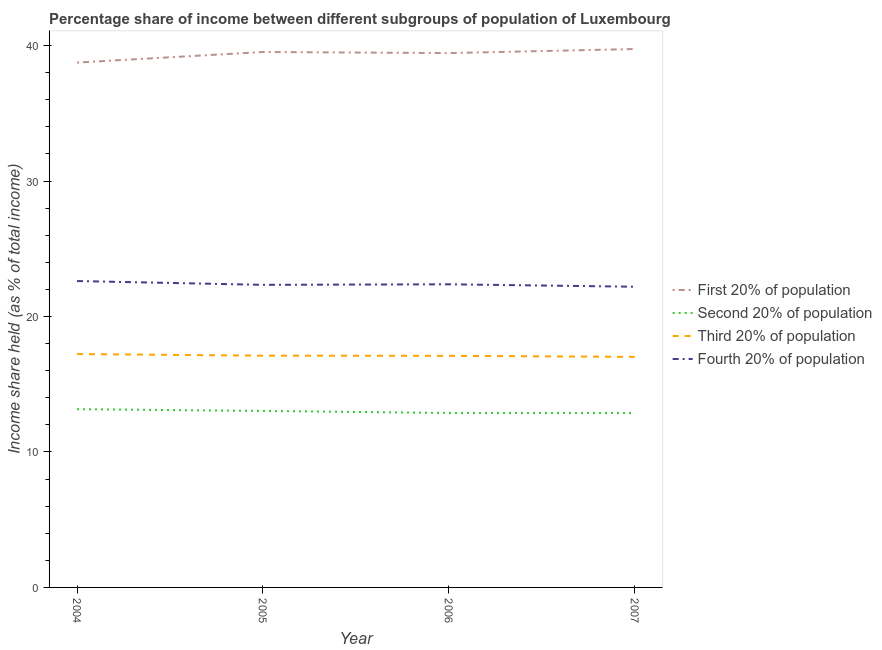How many different coloured lines are there?
Your answer should be compact. 4. Does the line corresponding to share of the income held by fourth 20% of the population intersect with the line corresponding to share of the income held by second 20% of the population?
Offer a terse response. No. What is the share of the income held by second 20% of the population in 2004?
Offer a very short reply. 13.16. Across all years, what is the maximum share of the income held by fourth 20% of the population?
Make the answer very short. 22.62. Across all years, what is the minimum share of the income held by second 20% of the population?
Give a very brief answer. 12.88. In which year was the share of the income held by second 20% of the population maximum?
Your response must be concise. 2004. In which year was the share of the income held by second 20% of the population minimum?
Provide a short and direct response. 2006. What is the total share of the income held by second 20% of the population in the graph?
Provide a short and direct response. 51.95. What is the difference between the share of the income held by third 20% of the population in 2005 and that in 2006?
Provide a succinct answer. 0.01. What is the difference between the share of the income held by first 20% of the population in 2007 and the share of the income held by third 20% of the population in 2005?
Your answer should be compact. 22.64. What is the average share of the income held by third 20% of the population per year?
Offer a very short reply. 17.12. In the year 2006, what is the difference between the share of the income held by fourth 20% of the population and share of the income held by second 20% of the population?
Offer a very short reply. 9.5. What is the ratio of the share of the income held by first 20% of the population in 2005 to that in 2007?
Make the answer very short. 0.99. Is the share of the income held by third 20% of the population in 2006 less than that in 2007?
Offer a very short reply. No. What is the difference between the highest and the second highest share of the income held by third 20% of the population?
Ensure brevity in your answer.  0.12. What is the difference between the highest and the lowest share of the income held by first 20% of the population?
Provide a short and direct response. 1. In how many years, is the share of the income held by third 20% of the population greater than the average share of the income held by third 20% of the population taken over all years?
Offer a terse response. 1. Is it the case that in every year, the sum of the share of the income held by first 20% of the population and share of the income held by second 20% of the population is greater than the share of the income held by third 20% of the population?
Make the answer very short. Yes. What is the difference between two consecutive major ticks on the Y-axis?
Your answer should be compact. 10. Does the graph contain any zero values?
Your answer should be compact. No. Does the graph contain grids?
Offer a terse response. No. How many legend labels are there?
Provide a succinct answer. 4. How are the legend labels stacked?
Offer a terse response. Vertical. What is the title of the graph?
Your answer should be compact. Percentage share of income between different subgroups of population of Luxembourg. Does "Budget management" appear as one of the legend labels in the graph?
Make the answer very short. No. What is the label or title of the X-axis?
Your response must be concise. Year. What is the label or title of the Y-axis?
Your response must be concise. Income share held (as % of total income). What is the Income share held (as % of total income) of First 20% of population in 2004?
Give a very brief answer. 38.75. What is the Income share held (as % of total income) in Second 20% of population in 2004?
Offer a very short reply. 13.16. What is the Income share held (as % of total income) in Third 20% of population in 2004?
Offer a terse response. 17.23. What is the Income share held (as % of total income) of Fourth 20% of population in 2004?
Your answer should be very brief. 22.62. What is the Income share held (as % of total income) in First 20% of population in 2005?
Provide a succinct answer. 39.53. What is the Income share held (as % of total income) of Second 20% of population in 2005?
Make the answer very short. 13.03. What is the Income share held (as % of total income) of Third 20% of population in 2005?
Keep it short and to the point. 17.11. What is the Income share held (as % of total income) in Fourth 20% of population in 2005?
Ensure brevity in your answer.  22.34. What is the Income share held (as % of total income) in First 20% of population in 2006?
Give a very brief answer. 39.45. What is the Income share held (as % of total income) of Second 20% of population in 2006?
Offer a terse response. 12.88. What is the Income share held (as % of total income) in Fourth 20% of population in 2006?
Your answer should be compact. 22.38. What is the Income share held (as % of total income) in First 20% of population in 2007?
Make the answer very short. 39.75. What is the Income share held (as % of total income) of Second 20% of population in 2007?
Make the answer very short. 12.88. What is the Income share held (as % of total income) in Third 20% of population in 2007?
Your answer should be compact. 17.02. Across all years, what is the maximum Income share held (as % of total income) in First 20% of population?
Offer a terse response. 39.75. Across all years, what is the maximum Income share held (as % of total income) in Second 20% of population?
Make the answer very short. 13.16. Across all years, what is the maximum Income share held (as % of total income) in Third 20% of population?
Offer a very short reply. 17.23. Across all years, what is the maximum Income share held (as % of total income) of Fourth 20% of population?
Give a very brief answer. 22.62. Across all years, what is the minimum Income share held (as % of total income) in First 20% of population?
Ensure brevity in your answer.  38.75. Across all years, what is the minimum Income share held (as % of total income) of Second 20% of population?
Keep it short and to the point. 12.88. Across all years, what is the minimum Income share held (as % of total income) in Third 20% of population?
Make the answer very short. 17.02. Across all years, what is the minimum Income share held (as % of total income) of Fourth 20% of population?
Provide a short and direct response. 22.2. What is the total Income share held (as % of total income) of First 20% of population in the graph?
Provide a short and direct response. 157.48. What is the total Income share held (as % of total income) of Second 20% of population in the graph?
Your answer should be compact. 51.95. What is the total Income share held (as % of total income) of Third 20% of population in the graph?
Offer a terse response. 68.46. What is the total Income share held (as % of total income) in Fourth 20% of population in the graph?
Your response must be concise. 89.54. What is the difference between the Income share held (as % of total income) of First 20% of population in 2004 and that in 2005?
Give a very brief answer. -0.78. What is the difference between the Income share held (as % of total income) of Second 20% of population in 2004 and that in 2005?
Give a very brief answer. 0.13. What is the difference between the Income share held (as % of total income) of Third 20% of population in 2004 and that in 2005?
Your answer should be compact. 0.12. What is the difference between the Income share held (as % of total income) of Fourth 20% of population in 2004 and that in 2005?
Offer a terse response. 0.28. What is the difference between the Income share held (as % of total income) in Second 20% of population in 2004 and that in 2006?
Keep it short and to the point. 0.28. What is the difference between the Income share held (as % of total income) of Third 20% of population in 2004 and that in 2006?
Offer a very short reply. 0.13. What is the difference between the Income share held (as % of total income) of Fourth 20% of population in 2004 and that in 2006?
Provide a short and direct response. 0.24. What is the difference between the Income share held (as % of total income) in Second 20% of population in 2004 and that in 2007?
Make the answer very short. 0.28. What is the difference between the Income share held (as % of total income) of Third 20% of population in 2004 and that in 2007?
Provide a succinct answer. 0.21. What is the difference between the Income share held (as % of total income) of Fourth 20% of population in 2004 and that in 2007?
Offer a terse response. 0.42. What is the difference between the Income share held (as % of total income) in First 20% of population in 2005 and that in 2006?
Give a very brief answer. 0.08. What is the difference between the Income share held (as % of total income) of Second 20% of population in 2005 and that in 2006?
Keep it short and to the point. 0.15. What is the difference between the Income share held (as % of total income) in Fourth 20% of population in 2005 and that in 2006?
Your response must be concise. -0.04. What is the difference between the Income share held (as % of total income) of First 20% of population in 2005 and that in 2007?
Give a very brief answer. -0.22. What is the difference between the Income share held (as % of total income) of Second 20% of population in 2005 and that in 2007?
Offer a very short reply. 0.15. What is the difference between the Income share held (as % of total income) in Third 20% of population in 2005 and that in 2007?
Provide a succinct answer. 0.09. What is the difference between the Income share held (as % of total income) of Fourth 20% of population in 2005 and that in 2007?
Your answer should be compact. 0.14. What is the difference between the Income share held (as % of total income) of First 20% of population in 2006 and that in 2007?
Your response must be concise. -0.3. What is the difference between the Income share held (as % of total income) of Third 20% of population in 2006 and that in 2007?
Ensure brevity in your answer.  0.08. What is the difference between the Income share held (as % of total income) in Fourth 20% of population in 2006 and that in 2007?
Offer a terse response. 0.18. What is the difference between the Income share held (as % of total income) in First 20% of population in 2004 and the Income share held (as % of total income) in Second 20% of population in 2005?
Provide a succinct answer. 25.72. What is the difference between the Income share held (as % of total income) in First 20% of population in 2004 and the Income share held (as % of total income) in Third 20% of population in 2005?
Your answer should be compact. 21.64. What is the difference between the Income share held (as % of total income) in First 20% of population in 2004 and the Income share held (as % of total income) in Fourth 20% of population in 2005?
Offer a terse response. 16.41. What is the difference between the Income share held (as % of total income) in Second 20% of population in 2004 and the Income share held (as % of total income) in Third 20% of population in 2005?
Offer a terse response. -3.95. What is the difference between the Income share held (as % of total income) of Second 20% of population in 2004 and the Income share held (as % of total income) of Fourth 20% of population in 2005?
Keep it short and to the point. -9.18. What is the difference between the Income share held (as % of total income) in Third 20% of population in 2004 and the Income share held (as % of total income) in Fourth 20% of population in 2005?
Your answer should be compact. -5.11. What is the difference between the Income share held (as % of total income) in First 20% of population in 2004 and the Income share held (as % of total income) in Second 20% of population in 2006?
Offer a very short reply. 25.87. What is the difference between the Income share held (as % of total income) of First 20% of population in 2004 and the Income share held (as % of total income) of Third 20% of population in 2006?
Provide a succinct answer. 21.65. What is the difference between the Income share held (as % of total income) in First 20% of population in 2004 and the Income share held (as % of total income) in Fourth 20% of population in 2006?
Make the answer very short. 16.37. What is the difference between the Income share held (as % of total income) of Second 20% of population in 2004 and the Income share held (as % of total income) of Third 20% of population in 2006?
Provide a short and direct response. -3.94. What is the difference between the Income share held (as % of total income) in Second 20% of population in 2004 and the Income share held (as % of total income) in Fourth 20% of population in 2006?
Make the answer very short. -9.22. What is the difference between the Income share held (as % of total income) of Third 20% of population in 2004 and the Income share held (as % of total income) of Fourth 20% of population in 2006?
Your answer should be compact. -5.15. What is the difference between the Income share held (as % of total income) in First 20% of population in 2004 and the Income share held (as % of total income) in Second 20% of population in 2007?
Provide a succinct answer. 25.87. What is the difference between the Income share held (as % of total income) in First 20% of population in 2004 and the Income share held (as % of total income) in Third 20% of population in 2007?
Provide a succinct answer. 21.73. What is the difference between the Income share held (as % of total income) of First 20% of population in 2004 and the Income share held (as % of total income) of Fourth 20% of population in 2007?
Keep it short and to the point. 16.55. What is the difference between the Income share held (as % of total income) in Second 20% of population in 2004 and the Income share held (as % of total income) in Third 20% of population in 2007?
Your answer should be compact. -3.86. What is the difference between the Income share held (as % of total income) of Second 20% of population in 2004 and the Income share held (as % of total income) of Fourth 20% of population in 2007?
Make the answer very short. -9.04. What is the difference between the Income share held (as % of total income) of Third 20% of population in 2004 and the Income share held (as % of total income) of Fourth 20% of population in 2007?
Make the answer very short. -4.97. What is the difference between the Income share held (as % of total income) in First 20% of population in 2005 and the Income share held (as % of total income) in Second 20% of population in 2006?
Offer a terse response. 26.65. What is the difference between the Income share held (as % of total income) of First 20% of population in 2005 and the Income share held (as % of total income) of Third 20% of population in 2006?
Your response must be concise. 22.43. What is the difference between the Income share held (as % of total income) in First 20% of population in 2005 and the Income share held (as % of total income) in Fourth 20% of population in 2006?
Keep it short and to the point. 17.15. What is the difference between the Income share held (as % of total income) of Second 20% of population in 2005 and the Income share held (as % of total income) of Third 20% of population in 2006?
Your response must be concise. -4.07. What is the difference between the Income share held (as % of total income) in Second 20% of population in 2005 and the Income share held (as % of total income) in Fourth 20% of population in 2006?
Give a very brief answer. -9.35. What is the difference between the Income share held (as % of total income) in Third 20% of population in 2005 and the Income share held (as % of total income) in Fourth 20% of population in 2006?
Offer a very short reply. -5.27. What is the difference between the Income share held (as % of total income) in First 20% of population in 2005 and the Income share held (as % of total income) in Second 20% of population in 2007?
Keep it short and to the point. 26.65. What is the difference between the Income share held (as % of total income) in First 20% of population in 2005 and the Income share held (as % of total income) in Third 20% of population in 2007?
Your response must be concise. 22.51. What is the difference between the Income share held (as % of total income) in First 20% of population in 2005 and the Income share held (as % of total income) in Fourth 20% of population in 2007?
Keep it short and to the point. 17.33. What is the difference between the Income share held (as % of total income) of Second 20% of population in 2005 and the Income share held (as % of total income) of Third 20% of population in 2007?
Your answer should be very brief. -3.99. What is the difference between the Income share held (as % of total income) in Second 20% of population in 2005 and the Income share held (as % of total income) in Fourth 20% of population in 2007?
Your answer should be compact. -9.17. What is the difference between the Income share held (as % of total income) of Third 20% of population in 2005 and the Income share held (as % of total income) of Fourth 20% of population in 2007?
Your answer should be very brief. -5.09. What is the difference between the Income share held (as % of total income) of First 20% of population in 2006 and the Income share held (as % of total income) of Second 20% of population in 2007?
Make the answer very short. 26.57. What is the difference between the Income share held (as % of total income) in First 20% of population in 2006 and the Income share held (as % of total income) in Third 20% of population in 2007?
Offer a terse response. 22.43. What is the difference between the Income share held (as % of total income) in First 20% of population in 2006 and the Income share held (as % of total income) in Fourth 20% of population in 2007?
Offer a terse response. 17.25. What is the difference between the Income share held (as % of total income) in Second 20% of population in 2006 and the Income share held (as % of total income) in Third 20% of population in 2007?
Your response must be concise. -4.14. What is the difference between the Income share held (as % of total income) of Second 20% of population in 2006 and the Income share held (as % of total income) of Fourth 20% of population in 2007?
Provide a short and direct response. -9.32. What is the difference between the Income share held (as % of total income) of Third 20% of population in 2006 and the Income share held (as % of total income) of Fourth 20% of population in 2007?
Your answer should be compact. -5.1. What is the average Income share held (as % of total income) in First 20% of population per year?
Ensure brevity in your answer.  39.37. What is the average Income share held (as % of total income) in Second 20% of population per year?
Offer a terse response. 12.99. What is the average Income share held (as % of total income) of Third 20% of population per year?
Your answer should be compact. 17.11. What is the average Income share held (as % of total income) in Fourth 20% of population per year?
Make the answer very short. 22.39. In the year 2004, what is the difference between the Income share held (as % of total income) of First 20% of population and Income share held (as % of total income) of Second 20% of population?
Offer a very short reply. 25.59. In the year 2004, what is the difference between the Income share held (as % of total income) of First 20% of population and Income share held (as % of total income) of Third 20% of population?
Provide a short and direct response. 21.52. In the year 2004, what is the difference between the Income share held (as % of total income) in First 20% of population and Income share held (as % of total income) in Fourth 20% of population?
Your answer should be compact. 16.13. In the year 2004, what is the difference between the Income share held (as % of total income) in Second 20% of population and Income share held (as % of total income) in Third 20% of population?
Your answer should be very brief. -4.07. In the year 2004, what is the difference between the Income share held (as % of total income) in Second 20% of population and Income share held (as % of total income) in Fourth 20% of population?
Provide a short and direct response. -9.46. In the year 2004, what is the difference between the Income share held (as % of total income) of Third 20% of population and Income share held (as % of total income) of Fourth 20% of population?
Your answer should be compact. -5.39. In the year 2005, what is the difference between the Income share held (as % of total income) in First 20% of population and Income share held (as % of total income) in Second 20% of population?
Your answer should be very brief. 26.5. In the year 2005, what is the difference between the Income share held (as % of total income) of First 20% of population and Income share held (as % of total income) of Third 20% of population?
Provide a succinct answer. 22.42. In the year 2005, what is the difference between the Income share held (as % of total income) of First 20% of population and Income share held (as % of total income) of Fourth 20% of population?
Offer a terse response. 17.19. In the year 2005, what is the difference between the Income share held (as % of total income) in Second 20% of population and Income share held (as % of total income) in Third 20% of population?
Make the answer very short. -4.08. In the year 2005, what is the difference between the Income share held (as % of total income) of Second 20% of population and Income share held (as % of total income) of Fourth 20% of population?
Give a very brief answer. -9.31. In the year 2005, what is the difference between the Income share held (as % of total income) in Third 20% of population and Income share held (as % of total income) in Fourth 20% of population?
Keep it short and to the point. -5.23. In the year 2006, what is the difference between the Income share held (as % of total income) of First 20% of population and Income share held (as % of total income) of Second 20% of population?
Your response must be concise. 26.57. In the year 2006, what is the difference between the Income share held (as % of total income) of First 20% of population and Income share held (as % of total income) of Third 20% of population?
Your answer should be compact. 22.35. In the year 2006, what is the difference between the Income share held (as % of total income) in First 20% of population and Income share held (as % of total income) in Fourth 20% of population?
Your answer should be very brief. 17.07. In the year 2006, what is the difference between the Income share held (as % of total income) in Second 20% of population and Income share held (as % of total income) in Third 20% of population?
Make the answer very short. -4.22. In the year 2006, what is the difference between the Income share held (as % of total income) in Second 20% of population and Income share held (as % of total income) in Fourth 20% of population?
Make the answer very short. -9.5. In the year 2006, what is the difference between the Income share held (as % of total income) of Third 20% of population and Income share held (as % of total income) of Fourth 20% of population?
Your response must be concise. -5.28. In the year 2007, what is the difference between the Income share held (as % of total income) of First 20% of population and Income share held (as % of total income) of Second 20% of population?
Make the answer very short. 26.87. In the year 2007, what is the difference between the Income share held (as % of total income) of First 20% of population and Income share held (as % of total income) of Third 20% of population?
Keep it short and to the point. 22.73. In the year 2007, what is the difference between the Income share held (as % of total income) in First 20% of population and Income share held (as % of total income) in Fourth 20% of population?
Give a very brief answer. 17.55. In the year 2007, what is the difference between the Income share held (as % of total income) in Second 20% of population and Income share held (as % of total income) in Third 20% of population?
Offer a terse response. -4.14. In the year 2007, what is the difference between the Income share held (as % of total income) of Second 20% of population and Income share held (as % of total income) of Fourth 20% of population?
Your response must be concise. -9.32. In the year 2007, what is the difference between the Income share held (as % of total income) of Third 20% of population and Income share held (as % of total income) of Fourth 20% of population?
Provide a short and direct response. -5.18. What is the ratio of the Income share held (as % of total income) in First 20% of population in 2004 to that in 2005?
Your answer should be very brief. 0.98. What is the ratio of the Income share held (as % of total income) of Fourth 20% of population in 2004 to that in 2005?
Offer a terse response. 1.01. What is the ratio of the Income share held (as % of total income) of First 20% of population in 2004 to that in 2006?
Your answer should be compact. 0.98. What is the ratio of the Income share held (as % of total income) of Second 20% of population in 2004 to that in 2006?
Offer a very short reply. 1.02. What is the ratio of the Income share held (as % of total income) in Third 20% of population in 2004 to that in 2006?
Your response must be concise. 1.01. What is the ratio of the Income share held (as % of total income) in Fourth 20% of population in 2004 to that in 2006?
Offer a very short reply. 1.01. What is the ratio of the Income share held (as % of total income) in First 20% of population in 2004 to that in 2007?
Make the answer very short. 0.97. What is the ratio of the Income share held (as % of total income) in Second 20% of population in 2004 to that in 2007?
Offer a terse response. 1.02. What is the ratio of the Income share held (as % of total income) in Third 20% of population in 2004 to that in 2007?
Provide a succinct answer. 1.01. What is the ratio of the Income share held (as % of total income) in Fourth 20% of population in 2004 to that in 2007?
Your answer should be compact. 1.02. What is the ratio of the Income share held (as % of total income) of First 20% of population in 2005 to that in 2006?
Provide a succinct answer. 1. What is the ratio of the Income share held (as % of total income) of Second 20% of population in 2005 to that in 2006?
Make the answer very short. 1.01. What is the ratio of the Income share held (as % of total income) of Fourth 20% of population in 2005 to that in 2006?
Provide a succinct answer. 1. What is the ratio of the Income share held (as % of total income) of Second 20% of population in 2005 to that in 2007?
Your answer should be compact. 1.01. What is the ratio of the Income share held (as % of total income) in Third 20% of population in 2005 to that in 2007?
Offer a very short reply. 1.01. What is the ratio of the Income share held (as % of total income) in Fourth 20% of population in 2005 to that in 2007?
Your answer should be compact. 1.01. What is the ratio of the Income share held (as % of total income) of First 20% of population in 2006 to that in 2007?
Your answer should be very brief. 0.99. What is the ratio of the Income share held (as % of total income) of Fourth 20% of population in 2006 to that in 2007?
Keep it short and to the point. 1.01. What is the difference between the highest and the second highest Income share held (as % of total income) in First 20% of population?
Keep it short and to the point. 0.22. What is the difference between the highest and the second highest Income share held (as % of total income) in Second 20% of population?
Provide a short and direct response. 0.13. What is the difference between the highest and the second highest Income share held (as % of total income) of Third 20% of population?
Your answer should be compact. 0.12. What is the difference between the highest and the second highest Income share held (as % of total income) of Fourth 20% of population?
Your response must be concise. 0.24. What is the difference between the highest and the lowest Income share held (as % of total income) of Second 20% of population?
Ensure brevity in your answer.  0.28. What is the difference between the highest and the lowest Income share held (as % of total income) in Third 20% of population?
Your answer should be very brief. 0.21. What is the difference between the highest and the lowest Income share held (as % of total income) of Fourth 20% of population?
Give a very brief answer. 0.42. 